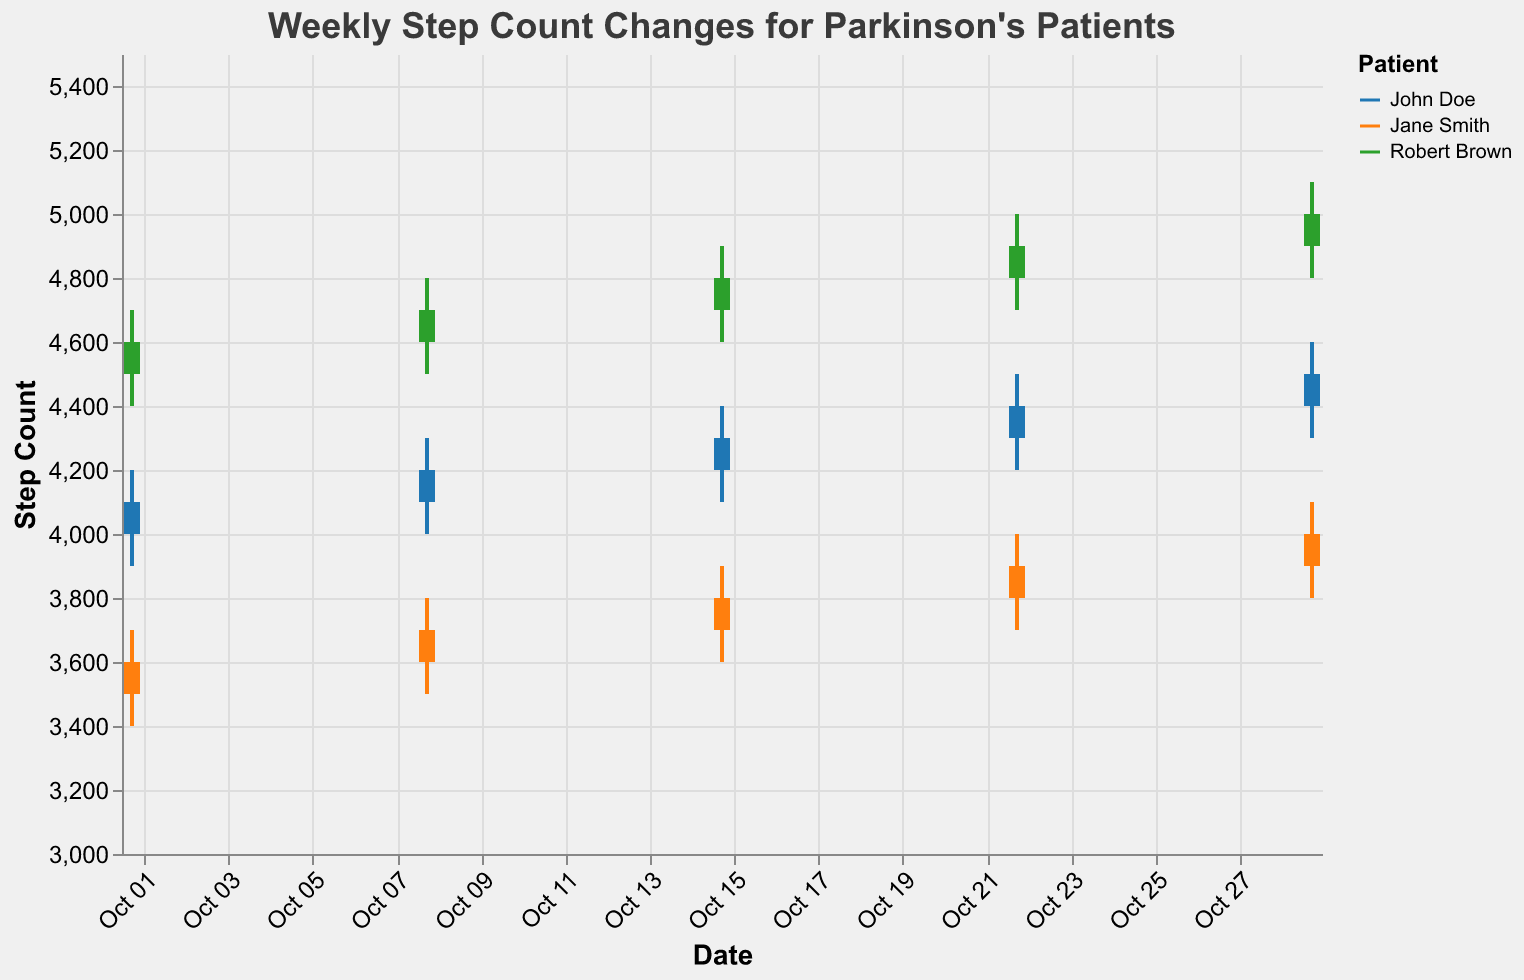What is the title of the plot? The title of the plot is usually displayed at the top of the figure. In this case, the title is "Weekly Step Count Changes for Parkinson's Patients".
Answer: Weekly Step Count Changes for Parkinson's Patients Which patient has the highest step count on October 29? To find this, look at the data points for October 29 and compare the High values for each patient. Robert Brown has the highest High value of 5100 on October 29.
Answer: Robert Brown What are the colors used to represent the different patients? The colors correspond to the patient legend on the right. John Doe is represented by blue, Jane Smith by orange, and Robert Brown by green.
Answer: Blue, Orange, Green Has John Doe's step count increased, decreased, or stayed the same over the five weeks? By comparing the Close values for John Doe over the weeks, we can trace the trend from Oct 1 to Oct 29: 4100, 4200, 4300, 4400, 4500. Since the values are consistently increasing, his step count has increased each week.
Answer: Increased Which week shows the greatest variance in step counts for any patient? To find this, calculate the difference between High and Low values for each week and compare them. The week of October 22 shows the greatest variance for Robert Brown, as the High is 5000 and the Low is 4700, giving a variance of 300 steps.
Answer: October 22 On which dates did Jane Smith surpass a step count of 4000? Review the High values for Jane Smith on each date. Jane Smith surpassed a step count of 4000 on October 29 (High = 4100).
Answer: October 29 Who showed the most consistent step count (least variance) over the five weeks? To determine this, compare the difference between the High and Low values for each patient over the five weeks. The patient with the smallest overall differences is Jane Smith, whose variances are: 300, 300, 300, 300, and 300.
Answer: Jane Smith What is the average 'Close' value for Robert Brown over the five weeks? Sum the Close values for Robert Brown for each week: 4600, 4700, 4800, 4900, 5000, then divide by 5 to get the average. (4600 + 4700 + 4800 + 4900 + 5000) / 5 = 4800 steps.
Answer: 4800 steps Compare the step count trends of Jane Smith and John Doe. Who has seen a more steady increase? Compare the Close values for both Jane Smith and John Doe across the weeks. Jane Smith's values are 3600, 3700, 3800, 3900, 4000 (steady increase of 100 each week). John Doe's values are 4100, 4200, 4300, 4400, 4500 (steady increase of 100 each week). Both show steady increases, but with the same increment per week.
Answer: Both steady 